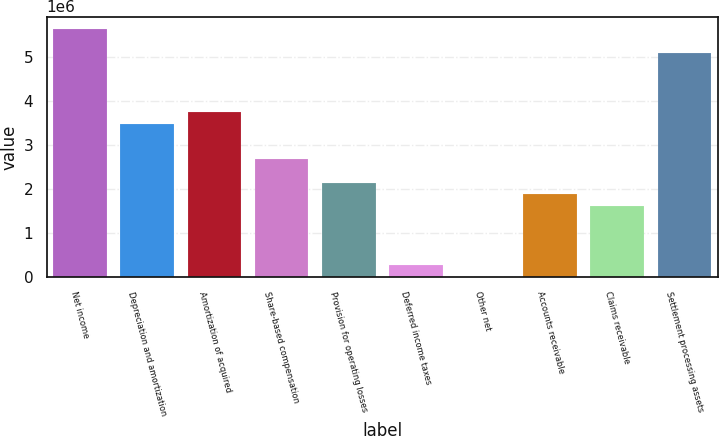Convert chart. <chart><loc_0><loc_0><loc_500><loc_500><bar_chart><fcel>Net income<fcel>Depreciation and amortization<fcel>Amortization of acquired<fcel>Share-based compensation<fcel>Provision for operating losses<fcel>Deferred income taxes<fcel>Other net<fcel>Accounts receivable<fcel>Claims receivable<fcel>Settlement processing assets<nl><fcel>5.64737e+06<fcel>3.49655e+06<fcel>3.76541e+06<fcel>2.69e+06<fcel>2.1523e+06<fcel>270336<fcel>1484<fcel>1.88345e+06<fcel>1.61459e+06<fcel>5.10966e+06<nl></chart> 